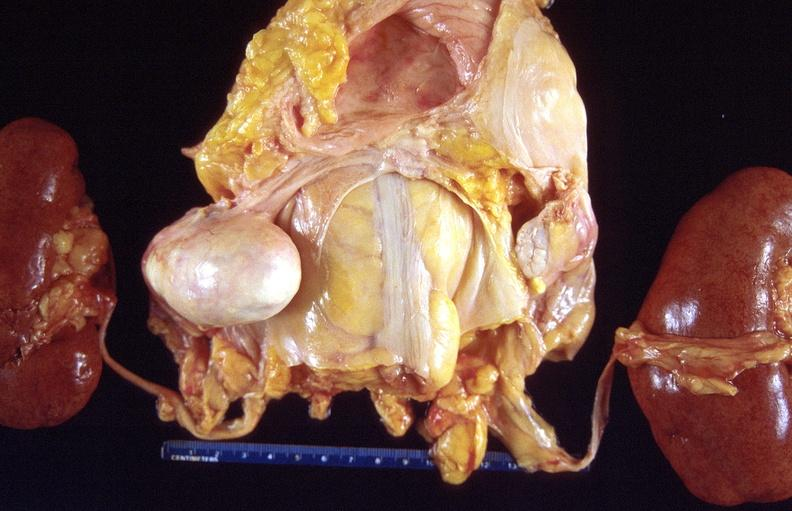where does this part belong to?
Answer the question using a single word or phrase. Female reproductive system 